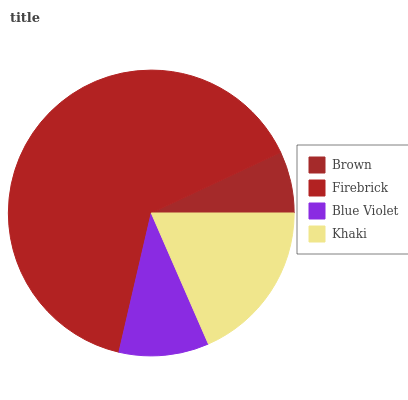Is Brown the minimum?
Answer yes or no. Yes. Is Firebrick the maximum?
Answer yes or no. Yes. Is Blue Violet the minimum?
Answer yes or no. No. Is Blue Violet the maximum?
Answer yes or no. No. Is Firebrick greater than Blue Violet?
Answer yes or no. Yes. Is Blue Violet less than Firebrick?
Answer yes or no. Yes. Is Blue Violet greater than Firebrick?
Answer yes or no. No. Is Firebrick less than Blue Violet?
Answer yes or no. No. Is Khaki the high median?
Answer yes or no. Yes. Is Blue Violet the low median?
Answer yes or no. Yes. Is Brown the high median?
Answer yes or no. No. Is Firebrick the low median?
Answer yes or no. No. 